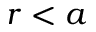<formula> <loc_0><loc_0><loc_500><loc_500>r < a</formula> 